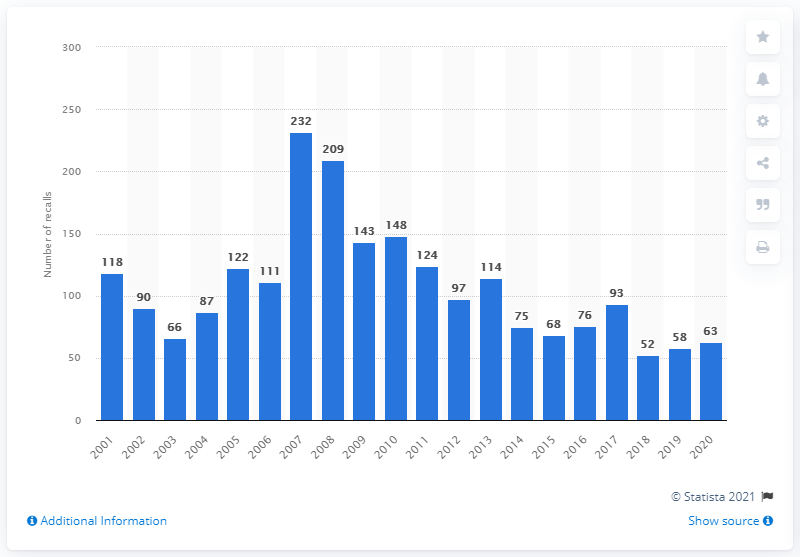Indicate a few pertinent items in this graphic. In 2020, a total of 63 children's products were the subject of a recall. 